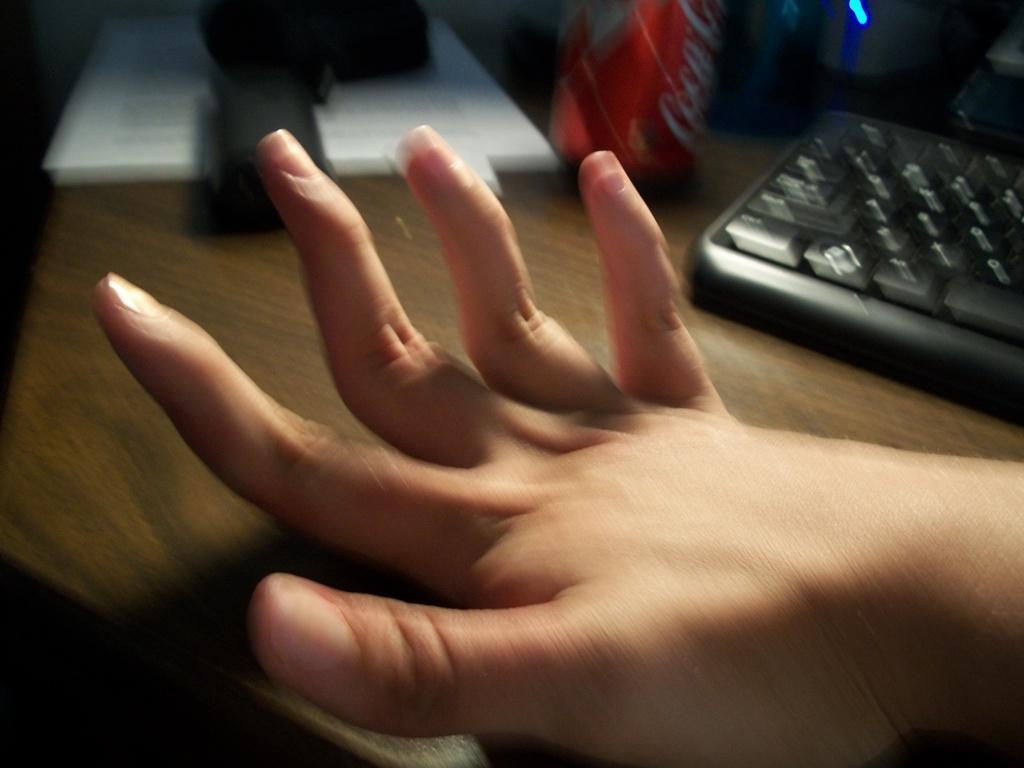Please provide a concise description of this image. In this picture we can see a person's hand, keyboard, tin and some objects on the wooden surface. 